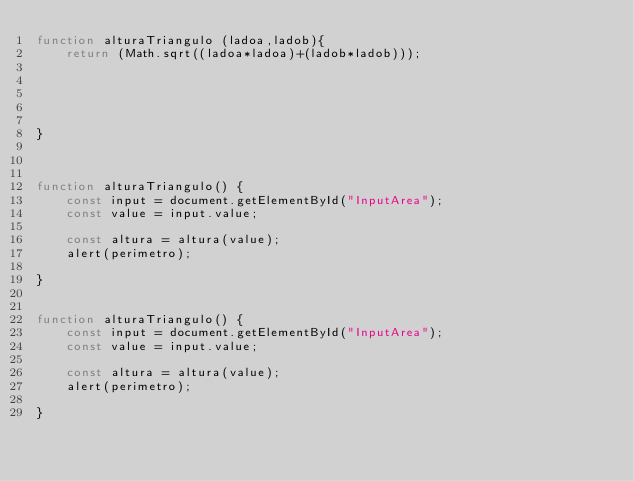Convert code to text. <code><loc_0><loc_0><loc_500><loc_500><_JavaScript_>function alturaTriangulo (ladoa,ladob){
    return (Math.sqrt((ladoa*ladoa)+(ladob*ladob)));
 




} 



function alturaTriangulo() {
    const input = document.getElementById("InputArea");
    const value = input.value;
  
    const altura = altura(value);
    alert(perimetro);

}


function alturaTriangulo() {
    const input = document.getElementById("InputArea");
    const value = input.value;
  
    const altura = altura(value);
    alert(perimetro);

}</code> 